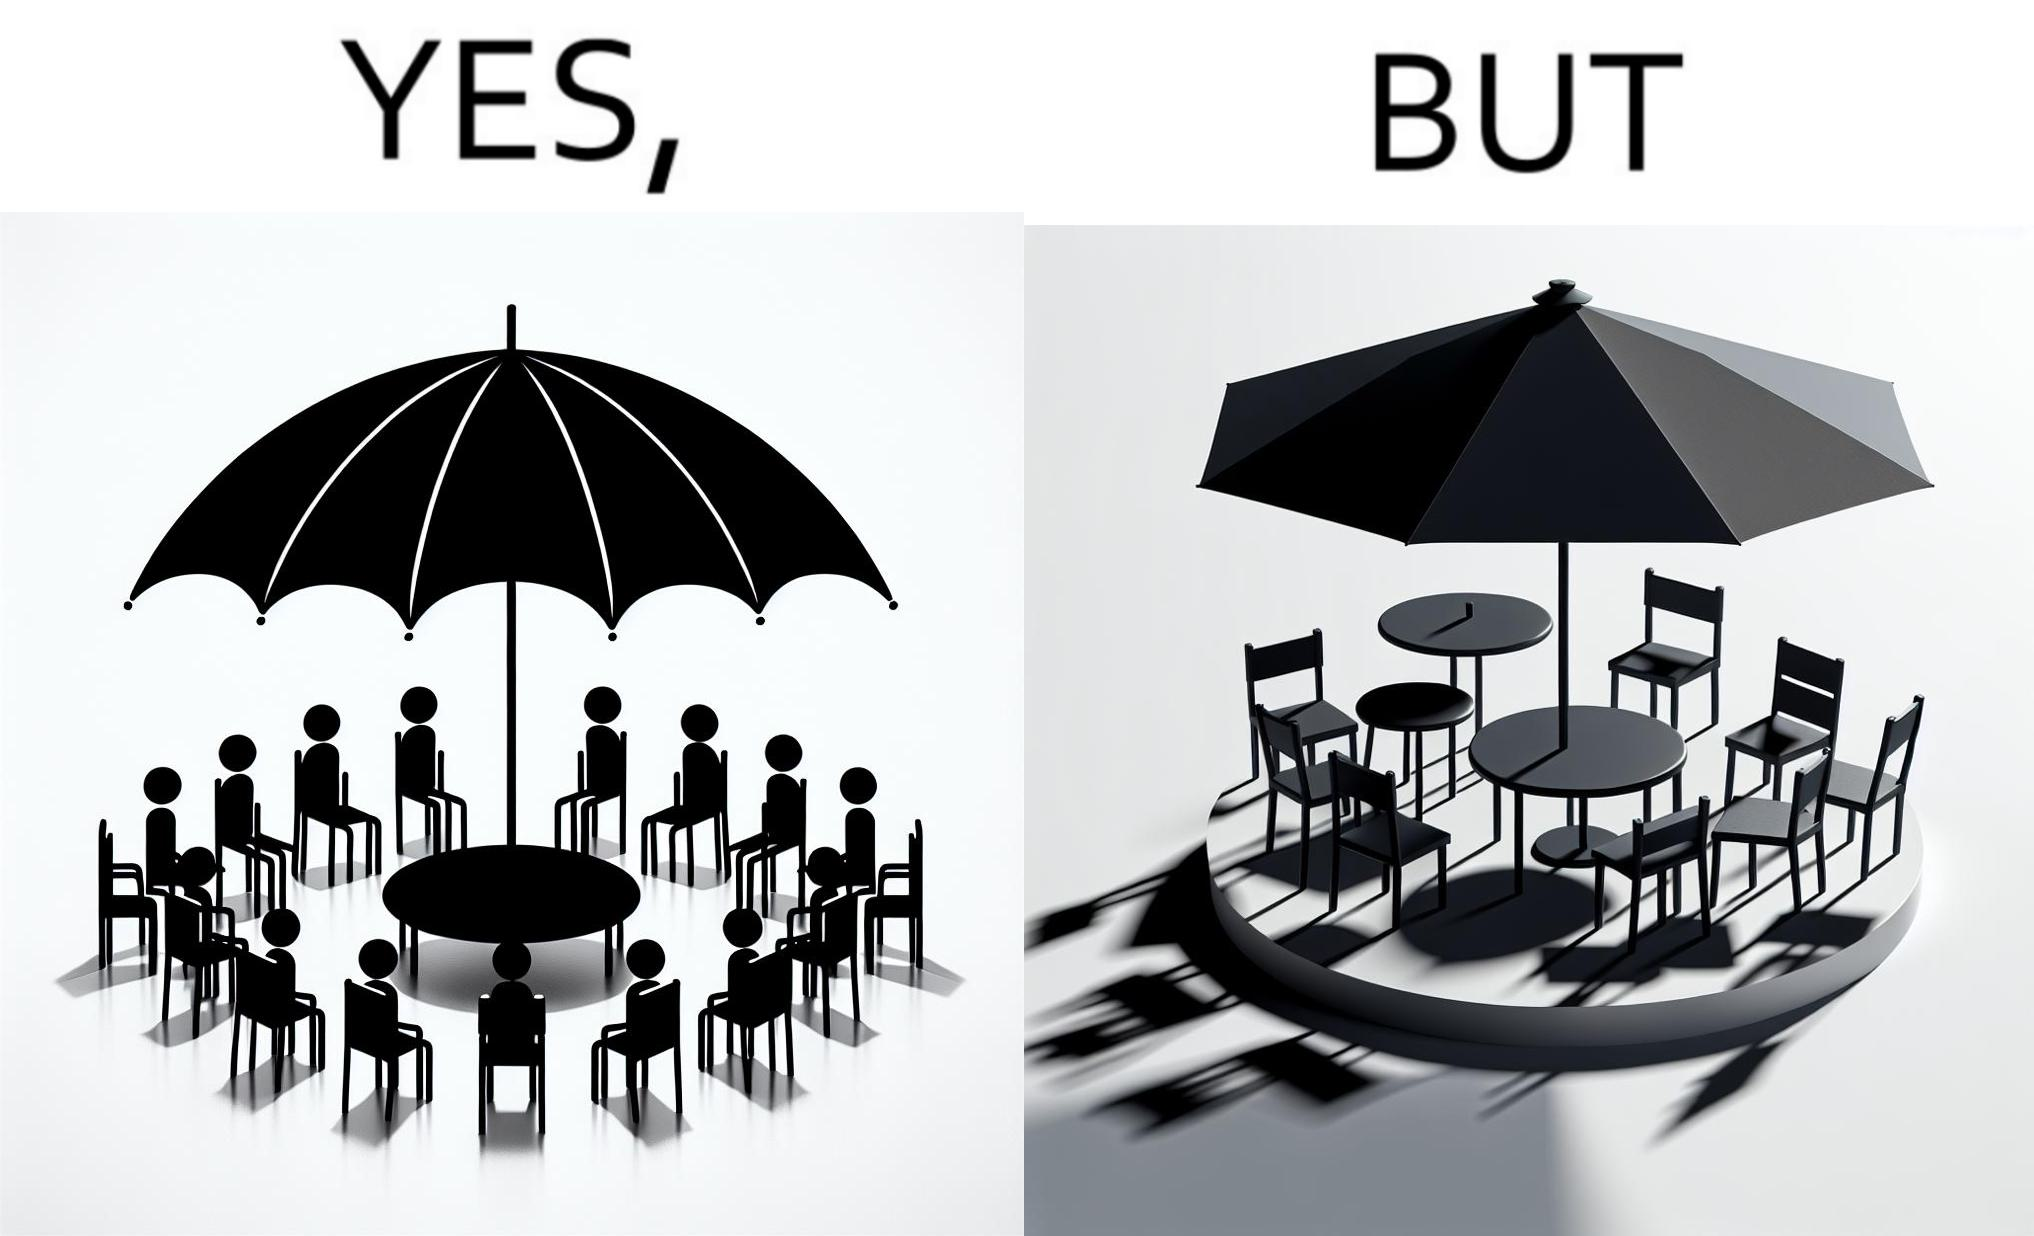What does this image depict? The image is ironical, as the umbrella is meant to provide shadow in the area where the chairs are present, but due to the orientation of the rays of the sun, all the chairs are in sunlight, and the umbrella is of no use in this situation. 